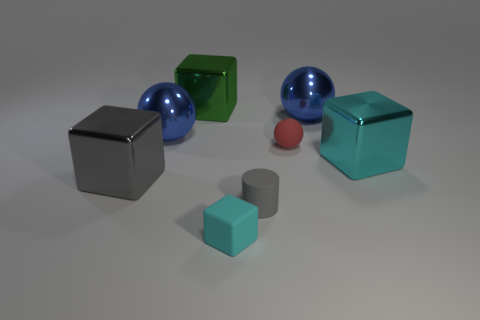Is there any other thing that is the same size as the gray block?
Keep it short and to the point. Yes. Are there any other things that have the same shape as the tiny gray rubber object?
Your answer should be very brief. No. Do the tiny cylinder and the big shiny cube to the left of the green thing have the same color?
Offer a terse response. Yes. There is a cylinder that is the same size as the red rubber thing; what color is it?
Your answer should be very brief. Gray. Are there any shiny blocks that are behind the matte thing right of the small gray rubber object?
Provide a short and direct response. Yes. How many cylinders are either tiny red things or big gray objects?
Offer a very short reply. 0. What is the size of the green thing that is right of the big blue object that is on the left side of the small thing in front of the gray cylinder?
Offer a terse response. Large. Are there any metal cubes right of the red matte ball?
Offer a terse response. Yes. The shiny thing that is the same color as the small matte block is what shape?
Your response must be concise. Cube. How many things are either blocks on the right side of the big gray metallic thing or small gray metal things?
Provide a short and direct response. 3. 